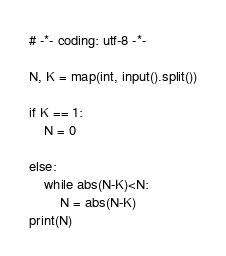<code> <loc_0><loc_0><loc_500><loc_500><_Python_># -*- coding: utf-8 -*-

N, K = map(int, input().split())

if K == 1:
    N = 0

else:
    while abs(N-K)<N:
        N = abs(N-K)
print(N)

</code> 